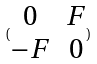<formula> <loc_0><loc_0><loc_500><loc_500>( \begin{matrix} 0 & F \\ - F & 0 \end{matrix} )</formula> 